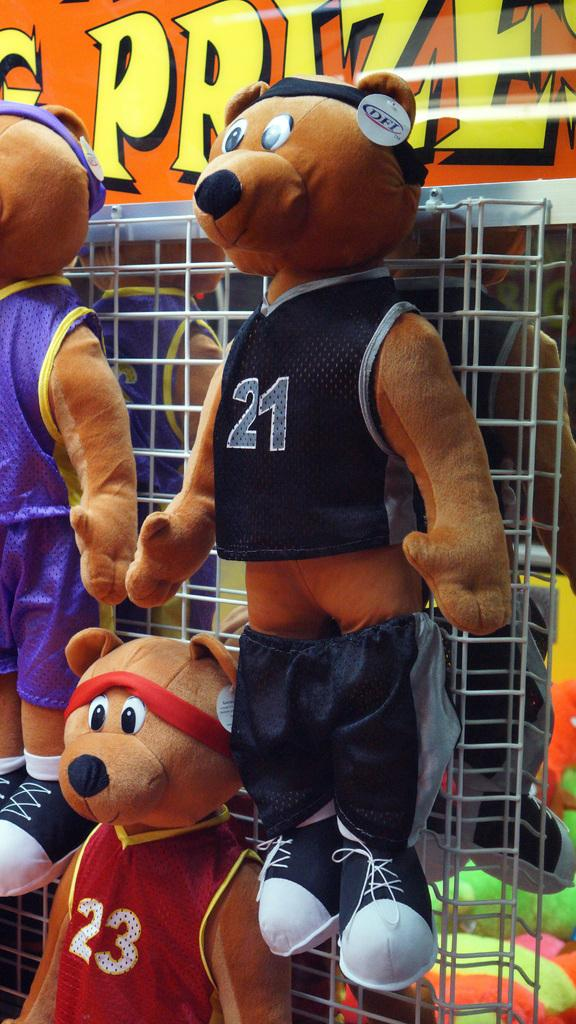Provide a one-sentence caption for the provided image. Bear wearing a jersey number 21 hanging on a fence. 